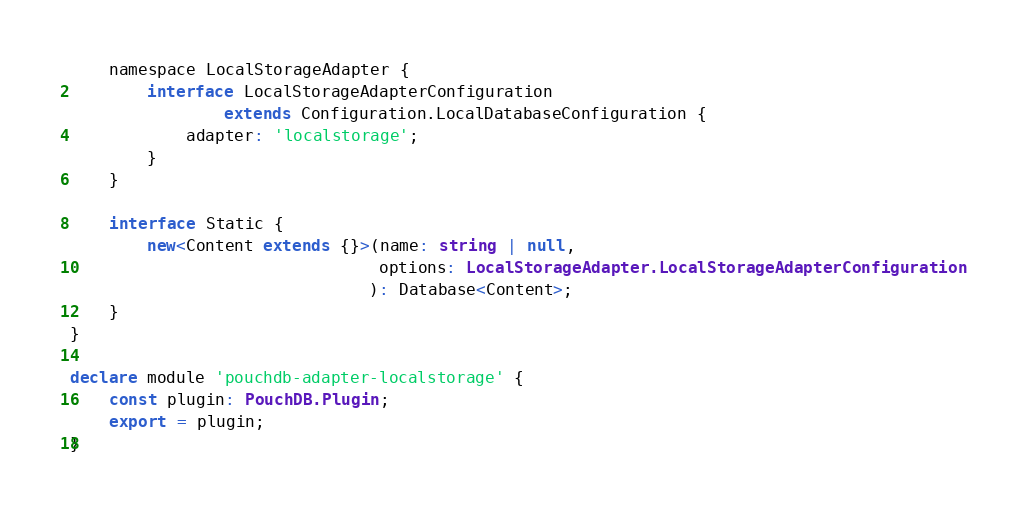<code> <loc_0><loc_0><loc_500><loc_500><_TypeScript_>    namespace LocalStorageAdapter {
        interface LocalStorageAdapterConfiguration
                extends Configuration.LocalDatabaseConfiguration {
            adapter: 'localstorage';
        }
    }

    interface Static {
        new<Content extends {}>(name: string | null,
                                options: LocalStorageAdapter.LocalStorageAdapterConfiguration
                               ): Database<Content>;
    }
}

declare module 'pouchdb-adapter-localstorage' {
    const plugin: PouchDB.Plugin;
    export = plugin;
}
</code> 